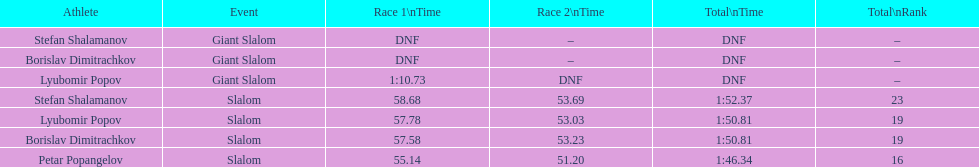What is the number of athletes to finish race one in the giant slalom? 1. 